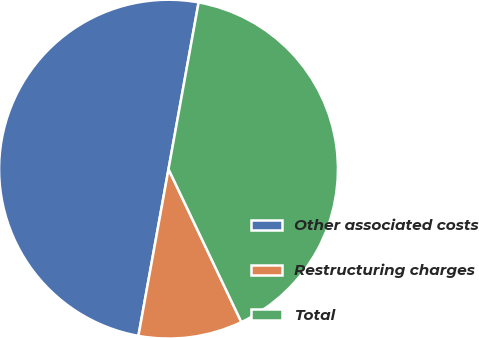Convert chart. <chart><loc_0><loc_0><loc_500><loc_500><pie_chart><fcel>Other associated costs<fcel>Restructuring charges<fcel>Total<nl><fcel>50.0%<fcel>9.92%<fcel>40.08%<nl></chart> 